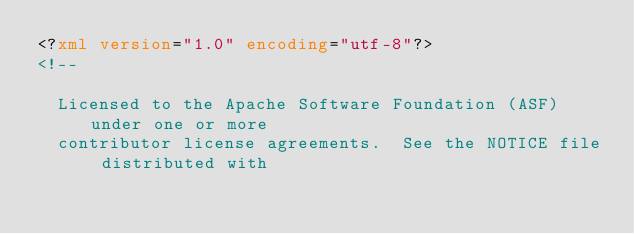<code> <loc_0><loc_0><loc_500><loc_500><_XML_><?xml version="1.0" encoding="utf-8"?>
<!--

  Licensed to the Apache Software Foundation (ASF) under one or more
  contributor license agreements.  See the NOTICE file distributed with</code> 